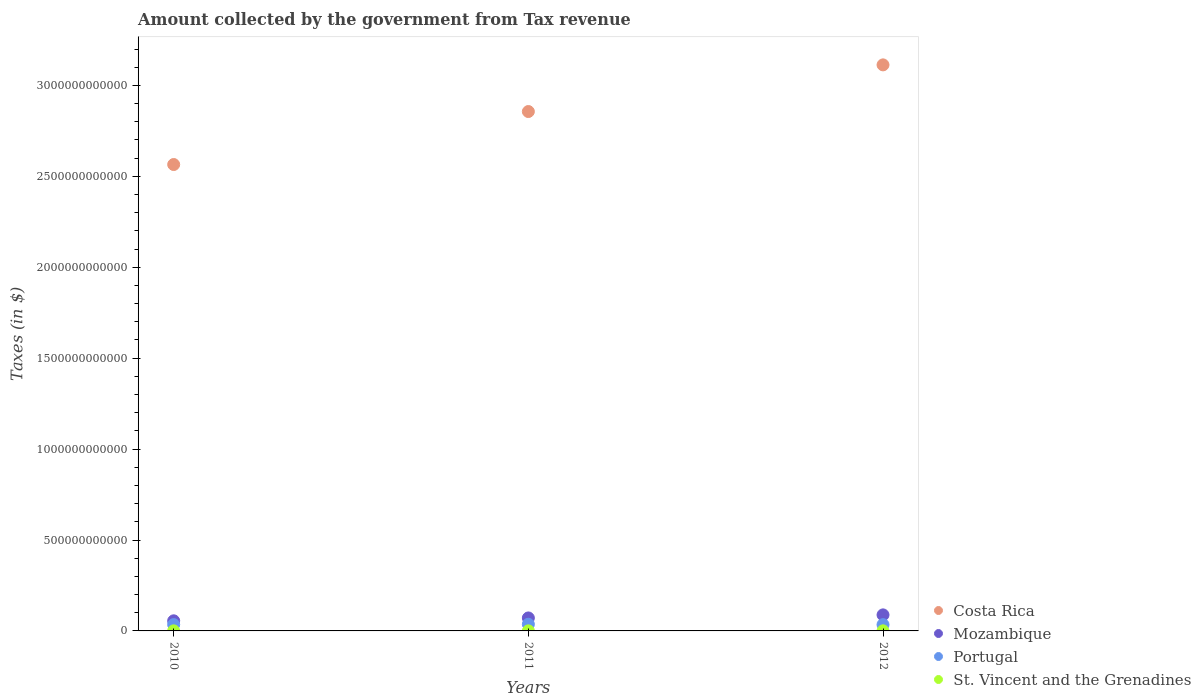How many different coloured dotlines are there?
Provide a succinct answer. 4. What is the amount collected by the government from tax revenue in Costa Rica in 2012?
Make the answer very short. 3.11e+12. Across all years, what is the maximum amount collected by the government from tax revenue in Portugal?
Give a very brief answer. 3.67e+1. Across all years, what is the minimum amount collected by the government from tax revenue in Portugal?
Make the answer very short. 3.45e+1. In which year was the amount collected by the government from tax revenue in Mozambique minimum?
Provide a short and direct response. 2010. What is the total amount collected by the government from tax revenue in Costa Rica in the graph?
Offer a very short reply. 8.53e+12. What is the difference between the amount collected by the government from tax revenue in Costa Rica in 2010 and that in 2011?
Make the answer very short. -2.91e+11. What is the difference between the amount collected by the government from tax revenue in St. Vincent and the Grenadines in 2011 and the amount collected by the government from tax revenue in Mozambique in 2010?
Your response must be concise. -5.52e+1. What is the average amount collected by the government from tax revenue in Portugal per year?
Provide a short and direct response. 3.53e+1. In the year 2011, what is the difference between the amount collected by the government from tax revenue in Mozambique and amount collected by the government from tax revenue in St. Vincent and the Grenadines?
Provide a short and direct response. 7.10e+1. What is the ratio of the amount collected by the government from tax revenue in Mozambique in 2010 to that in 2011?
Your response must be concise. 0.78. Is the difference between the amount collected by the government from tax revenue in Mozambique in 2010 and 2012 greater than the difference between the amount collected by the government from tax revenue in St. Vincent and the Grenadines in 2010 and 2012?
Ensure brevity in your answer.  No. What is the difference between the highest and the second highest amount collected by the government from tax revenue in Mozambique?
Provide a succinct answer. 1.68e+1. What is the difference between the highest and the lowest amount collected by the government from tax revenue in St. Vincent and the Grenadines?
Your answer should be very brief. 1.85e+07. Is it the case that in every year, the sum of the amount collected by the government from tax revenue in Costa Rica and amount collected by the government from tax revenue in Mozambique  is greater than the sum of amount collected by the government from tax revenue in Portugal and amount collected by the government from tax revenue in St. Vincent and the Grenadines?
Your answer should be compact. Yes. Is it the case that in every year, the sum of the amount collected by the government from tax revenue in Portugal and amount collected by the government from tax revenue in Mozambique  is greater than the amount collected by the government from tax revenue in St. Vincent and the Grenadines?
Provide a succinct answer. Yes. Does the amount collected by the government from tax revenue in St. Vincent and the Grenadines monotonically increase over the years?
Provide a succinct answer. No. Is the amount collected by the government from tax revenue in Mozambique strictly greater than the amount collected by the government from tax revenue in Costa Rica over the years?
Give a very brief answer. No. Is the amount collected by the government from tax revenue in Portugal strictly less than the amount collected by the government from tax revenue in Mozambique over the years?
Your response must be concise. Yes. How many dotlines are there?
Offer a terse response. 4. What is the difference between two consecutive major ticks on the Y-axis?
Offer a very short reply. 5.00e+11. Are the values on the major ticks of Y-axis written in scientific E-notation?
Keep it short and to the point. No. Where does the legend appear in the graph?
Offer a very short reply. Bottom right. How many legend labels are there?
Offer a very short reply. 4. How are the legend labels stacked?
Your answer should be very brief. Vertical. What is the title of the graph?
Your answer should be very brief. Amount collected by the government from Tax revenue. What is the label or title of the X-axis?
Your response must be concise. Years. What is the label or title of the Y-axis?
Make the answer very short. Taxes (in $). What is the Taxes (in $) in Costa Rica in 2010?
Offer a very short reply. 2.56e+12. What is the Taxes (in $) of Mozambique in 2010?
Offer a terse response. 5.56e+1. What is the Taxes (in $) in Portugal in 2010?
Offer a very short reply. 3.47e+1. What is the Taxes (in $) of St. Vincent and the Grenadines in 2010?
Your answer should be compact. 4.22e+08. What is the Taxes (in $) in Costa Rica in 2011?
Your answer should be compact. 2.86e+12. What is the Taxes (in $) in Mozambique in 2011?
Offer a very short reply. 7.14e+1. What is the Taxes (in $) in Portugal in 2011?
Ensure brevity in your answer.  3.67e+1. What is the Taxes (in $) of St. Vincent and the Grenadines in 2011?
Provide a succinct answer. 4.12e+08. What is the Taxes (in $) of Costa Rica in 2012?
Keep it short and to the point. 3.11e+12. What is the Taxes (in $) of Mozambique in 2012?
Keep it short and to the point. 8.82e+1. What is the Taxes (in $) of Portugal in 2012?
Offer a terse response. 3.45e+1. What is the Taxes (in $) of St. Vincent and the Grenadines in 2012?
Provide a short and direct response. 4.31e+08. Across all years, what is the maximum Taxes (in $) in Costa Rica?
Your response must be concise. 3.11e+12. Across all years, what is the maximum Taxes (in $) of Mozambique?
Give a very brief answer. 8.82e+1. Across all years, what is the maximum Taxes (in $) in Portugal?
Offer a very short reply. 3.67e+1. Across all years, what is the maximum Taxes (in $) of St. Vincent and the Grenadines?
Ensure brevity in your answer.  4.31e+08. Across all years, what is the minimum Taxes (in $) of Costa Rica?
Make the answer very short. 2.56e+12. Across all years, what is the minimum Taxes (in $) in Mozambique?
Make the answer very short. 5.56e+1. Across all years, what is the minimum Taxes (in $) of Portugal?
Your response must be concise. 3.45e+1. Across all years, what is the minimum Taxes (in $) of St. Vincent and the Grenadines?
Your answer should be very brief. 4.12e+08. What is the total Taxes (in $) of Costa Rica in the graph?
Give a very brief answer. 8.53e+12. What is the total Taxes (in $) in Mozambique in the graph?
Make the answer very short. 2.15e+11. What is the total Taxes (in $) in Portugal in the graph?
Your response must be concise. 1.06e+11. What is the total Taxes (in $) of St. Vincent and the Grenadines in the graph?
Give a very brief answer. 1.26e+09. What is the difference between the Taxes (in $) in Costa Rica in 2010 and that in 2011?
Offer a very short reply. -2.91e+11. What is the difference between the Taxes (in $) of Mozambique in 2010 and that in 2011?
Keep it short and to the point. -1.58e+1. What is the difference between the Taxes (in $) of Portugal in 2010 and that in 2011?
Offer a very short reply. -1.95e+09. What is the difference between the Taxes (in $) in St. Vincent and the Grenadines in 2010 and that in 2011?
Your answer should be compact. 9.40e+06. What is the difference between the Taxes (in $) in Costa Rica in 2010 and that in 2012?
Offer a terse response. -5.48e+11. What is the difference between the Taxes (in $) of Mozambique in 2010 and that in 2012?
Your response must be concise. -3.26e+1. What is the difference between the Taxes (in $) in Portugal in 2010 and that in 2012?
Your answer should be very brief. 2.07e+08. What is the difference between the Taxes (in $) in St. Vincent and the Grenadines in 2010 and that in 2012?
Provide a succinct answer. -9.10e+06. What is the difference between the Taxes (in $) of Costa Rica in 2011 and that in 2012?
Provide a short and direct response. -2.57e+11. What is the difference between the Taxes (in $) in Mozambique in 2011 and that in 2012?
Provide a short and direct response. -1.68e+1. What is the difference between the Taxes (in $) of Portugal in 2011 and that in 2012?
Your answer should be compact. 2.15e+09. What is the difference between the Taxes (in $) in St. Vincent and the Grenadines in 2011 and that in 2012?
Give a very brief answer. -1.85e+07. What is the difference between the Taxes (in $) of Costa Rica in 2010 and the Taxes (in $) of Mozambique in 2011?
Your response must be concise. 2.49e+12. What is the difference between the Taxes (in $) in Costa Rica in 2010 and the Taxes (in $) in Portugal in 2011?
Your answer should be very brief. 2.53e+12. What is the difference between the Taxes (in $) of Costa Rica in 2010 and the Taxes (in $) of St. Vincent and the Grenadines in 2011?
Give a very brief answer. 2.56e+12. What is the difference between the Taxes (in $) in Mozambique in 2010 and the Taxes (in $) in Portugal in 2011?
Make the answer very short. 1.89e+1. What is the difference between the Taxes (in $) in Mozambique in 2010 and the Taxes (in $) in St. Vincent and the Grenadines in 2011?
Provide a succinct answer. 5.52e+1. What is the difference between the Taxes (in $) of Portugal in 2010 and the Taxes (in $) of St. Vincent and the Grenadines in 2011?
Provide a short and direct response. 3.43e+1. What is the difference between the Taxes (in $) in Costa Rica in 2010 and the Taxes (in $) in Mozambique in 2012?
Keep it short and to the point. 2.48e+12. What is the difference between the Taxes (in $) in Costa Rica in 2010 and the Taxes (in $) in Portugal in 2012?
Offer a terse response. 2.53e+12. What is the difference between the Taxes (in $) in Costa Rica in 2010 and the Taxes (in $) in St. Vincent and the Grenadines in 2012?
Keep it short and to the point. 2.56e+12. What is the difference between the Taxes (in $) of Mozambique in 2010 and the Taxes (in $) of Portugal in 2012?
Keep it short and to the point. 2.11e+1. What is the difference between the Taxes (in $) of Mozambique in 2010 and the Taxes (in $) of St. Vincent and the Grenadines in 2012?
Your response must be concise. 5.52e+1. What is the difference between the Taxes (in $) of Portugal in 2010 and the Taxes (in $) of St. Vincent and the Grenadines in 2012?
Your response must be concise. 3.43e+1. What is the difference between the Taxes (in $) in Costa Rica in 2011 and the Taxes (in $) in Mozambique in 2012?
Keep it short and to the point. 2.77e+12. What is the difference between the Taxes (in $) of Costa Rica in 2011 and the Taxes (in $) of Portugal in 2012?
Offer a terse response. 2.82e+12. What is the difference between the Taxes (in $) in Costa Rica in 2011 and the Taxes (in $) in St. Vincent and the Grenadines in 2012?
Make the answer very short. 2.86e+12. What is the difference between the Taxes (in $) in Mozambique in 2011 and the Taxes (in $) in Portugal in 2012?
Offer a very short reply. 3.69e+1. What is the difference between the Taxes (in $) of Mozambique in 2011 and the Taxes (in $) of St. Vincent and the Grenadines in 2012?
Offer a terse response. 7.10e+1. What is the difference between the Taxes (in $) in Portugal in 2011 and the Taxes (in $) in St. Vincent and the Grenadines in 2012?
Offer a terse response. 3.62e+1. What is the average Taxes (in $) in Costa Rica per year?
Keep it short and to the point. 2.84e+12. What is the average Taxes (in $) in Mozambique per year?
Offer a very short reply. 7.17e+1. What is the average Taxes (in $) in Portugal per year?
Give a very brief answer. 3.53e+1. What is the average Taxes (in $) of St. Vincent and the Grenadines per year?
Give a very brief answer. 4.21e+08. In the year 2010, what is the difference between the Taxes (in $) in Costa Rica and Taxes (in $) in Mozambique?
Your answer should be compact. 2.51e+12. In the year 2010, what is the difference between the Taxes (in $) in Costa Rica and Taxes (in $) in Portugal?
Your answer should be very brief. 2.53e+12. In the year 2010, what is the difference between the Taxes (in $) in Costa Rica and Taxes (in $) in St. Vincent and the Grenadines?
Your response must be concise. 2.56e+12. In the year 2010, what is the difference between the Taxes (in $) in Mozambique and Taxes (in $) in Portugal?
Keep it short and to the point. 2.09e+1. In the year 2010, what is the difference between the Taxes (in $) in Mozambique and Taxes (in $) in St. Vincent and the Grenadines?
Keep it short and to the point. 5.52e+1. In the year 2010, what is the difference between the Taxes (in $) in Portugal and Taxes (in $) in St. Vincent and the Grenadines?
Provide a short and direct response. 3.43e+1. In the year 2011, what is the difference between the Taxes (in $) in Costa Rica and Taxes (in $) in Mozambique?
Provide a short and direct response. 2.78e+12. In the year 2011, what is the difference between the Taxes (in $) in Costa Rica and Taxes (in $) in Portugal?
Provide a short and direct response. 2.82e+12. In the year 2011, what is the difference between the Taxes (in $) in Costa Rica and Taxes (in $) in St. Vincent and the Grenadines?
Offer a terse response. 2.86e+12. In the year 2011, what is the difference between the Taxes (in $) in Mozambique and Taxes (in $) in Portugal?
Ensure brevity in your answer.  3.47e+1. In the year 2011, what is the difference between the Taxes (in $) of Mozambique and Taxes (in $) of St. Vincent and the Grenadines?
Your answer should be compact. 7.10e+1. In the year 2011, what is the difference between the Taxes (in $) in Portugal and Taxes (in $) in St. Vincent and the Grenadines?
Ensure brevity in your answer.  3.63e+1. In the year 2012, what is the difference between the Taxes (in $) of Costa Rica and Taxes (in $) of Mozambique?
Ensure brevity in your answer.  3.02e+12. In the year 2012, what is the difference between the Taxes (in $) of Costa Rica and Taxes (in $) of Portugal?
Provide a succinct answer. 3.08e+12. In the year 2012, what is the difference between the Taxes (in $) in Costa Rica and Taxes (in $) in St. Vincent and the Grenadines?
Make the answer very short. 3.11e+12. In the year 2012, what is the difference between the Taxes (in $) in Mozambique and Taxes (in $) in Portugal?
Provide a succinct answer. 5.37e+1. In the year 2012, what is the difference between the Taxes (in $) in Mozambique and Taxes (in $) in St. Vincent and the Grenadines?
Your response must be concise. 8.78e+1. In the year 2012, what is the difference between the Taxes (in $) in Portugal and Taxes (in $) in St. Vincent and the Grenadines?
Offer a terse response. 3.41e+1. What is the ratio of the Taxes (in $) in Costa Rica in 2010 to that in 2011?
Offer a terse response. 0.9. What is the ratio of the Taxes (in $) in Mozambique in 2010 to that in 2011?
Your response must be concise. 0.78. What is the ratio of the Taxes (in $) of Portugal in 2010 to that in 2011?
Your answer should be very brief. 0.95. What is the ratio of the Taxes (in $) in St. Vincent and the Grenadines in 2010 to that in 2011?
Your response must be concise. 1.02. What is the ratio of the Taxes (in $) in Costa Rica in 2010 to that in 2012?
Your response must be concise. 0.82. What is the ratio of the Taxes (in $) in Mozambique in 2010 to that in 2012?
Keep it short and to the point. 0.63. What is the ratio of the Taxes (in $) of Portugal in 2010 to that in 2012?
Your response must be concise. 1.01. What is the ratio of the Taxes (in $) in St. Vincent and the Grenadines in 2010 to that in 2012?
Provide a succinct answer. 0.98. What is the ratio of the Taxes (in $) of Costa Rica in 2011 to that in 2012?
Make the answer very short. 0.92. What is the ratio of the Taxes (in $) in Mozambique in 2011 to that in 2012?
Your answer should be compact. 0.81. What is the ratio of the Taxes (in $) of Portugal in 2011 to that in 2012?
Your answer should be very brief. 1.06. What is the ratio of the Taxes (in $) in St. Vincent and the Grenadines in 2011 to that in 2012?
Your answer should be compact. 0.96. What is the difference between the highest and the second highest Taxes (in $) of Costa Rica?
Keep it short and to the point. 2.57e+11. What is the difference between the highest and the second highest Taxes (in $) in Mozambique?
Your response must be concise. 1.68e+1. What is the difference between the highest and the second highest Taxes (in $) in Portugal?
Provide a succinct answer. 1.95e+09. What is the difference between the highest and the second highest Taxes (in $) of St. Vincent and the Grenadines?
Your answer should be compact. 9.10e+06. What is the difference between the highest and the lowest Taxes (in $) of Costa Rica?
Ensure brevity in your answer.  5.48e+11. What is the difference between the highest and the lowest Taxes (in $) in Mozambique?
Offer a very short reply. 3.26e+1. What is the difference between the highest and the lowest Taxes (in $) in Portugal?
Give a very brief answer. 2.15e+09. What is the difference between the highest and the lowest Taxes (in $) in St. Vincent and the Grenadines?
Your answer should be compact. 1.85e+07. 